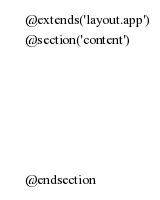<code> <loc_0><loc_0><loc_500><loc_500><_PHP_>@extends('layout.app')
@section('content')






@endsection</code> 